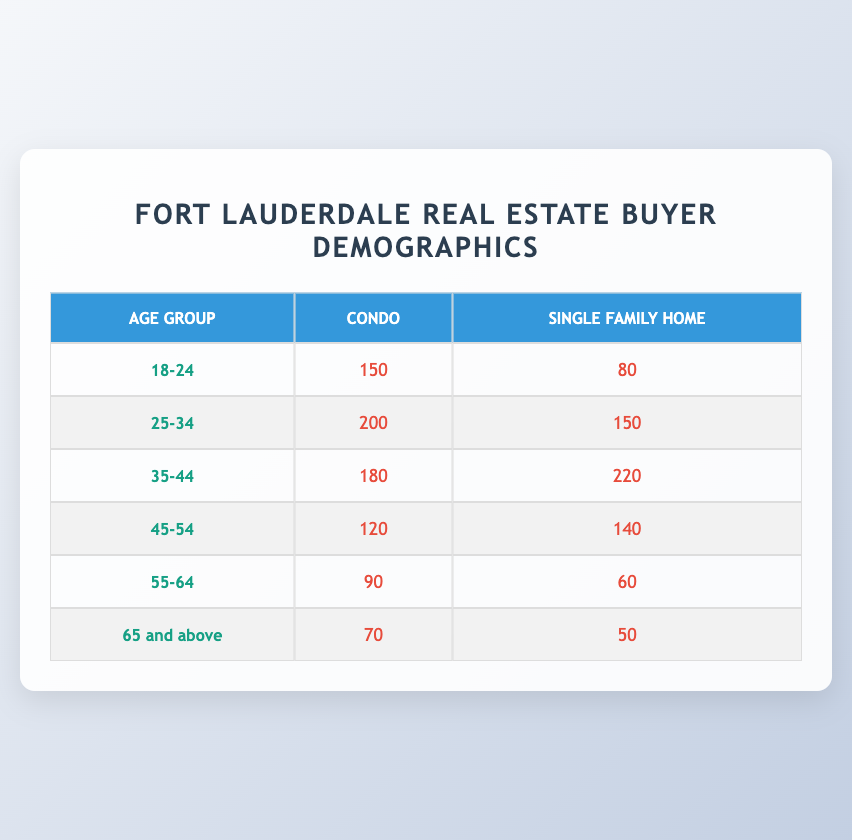What is the number of buyers aged 25-34 for Single Family Homes? From the table, in the row for the age group "25-34," we can directly look under the column for "Single Family Home." The number of buyers is 150.
Answer: 150 How many buyers aged 35-44 bought Condos? By checking the row labeled "35-44" and looking under the "Condo" column, we find that there were 180 buyers in that age group who bought Condos.
Answer: 180 What is the total number of buyers aged 45-54? To calculate the total number of buyers in this age group, we add the number of buyers from both property types: 120 (Condo) + 140 (Single Family Home) = 260. Therefore, the total is 260 buyers.
Answer: 260 Is it true that more buyers in the age group 55-64 bought Condos than those who bought Single Family Homes? Looking at the data for the age group "55-64," we see that 90 buyers purchased Condos while only 60 purchased Single Family Homes. Since 90 is greater than 60, the answer is true.
Answer: Yes What is the percentage of buyers aged 18-24 that chose Single Family Homes out of the total buyers in that age group? First, we find the total number of buyers aged 18-24: 150 (Condo) + 80 (Single Family Home) = 230. Then, the percentage of buyers choosing Single Family Homes is (80 / 230) * 100 = about 34.78%.
Answer: 34.78% Which property type has the highest number of buyers in the age group 35-44? In the age group "35-44," under the property type columns, 180 buyers bought Condos, and 220 bought Single Family Homes. Thus, Single Family Homes have the higher number.
Answer: Single Family Home What is the difference in the number of buyers between the age groups 45-54 and 35-44 for Condos? We find the number of buyers for Condos in the age groups: 120 (for 45-54) and 180 (for 35-44). The difference is calculated as follows: 180 - 120 = 60. So, there are 60 more buyers in the 35-44 age group for Condos compared to the 45-54 age group.
Answer: 60 In the age group 65 and above, which property type had more buyers? For the age group "65 and above," the number of buyers for Condos is 70, while for Single Family Homes it is 50. Since 70 is greater than 50, Condos had more buyers.
Answer: Condo 